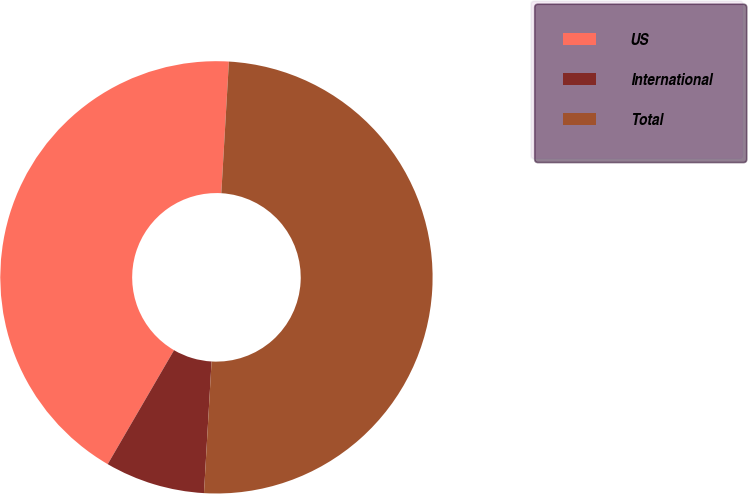Convert chart to OTSL. <chart><loc_0><loc_0><loc_500><loc_500><pie_chart><fcel>US<fcel>International<fcel>Total<nl><fcel>42.53%<fcel>7.47%<fcel>50.0%<nl></chart> 